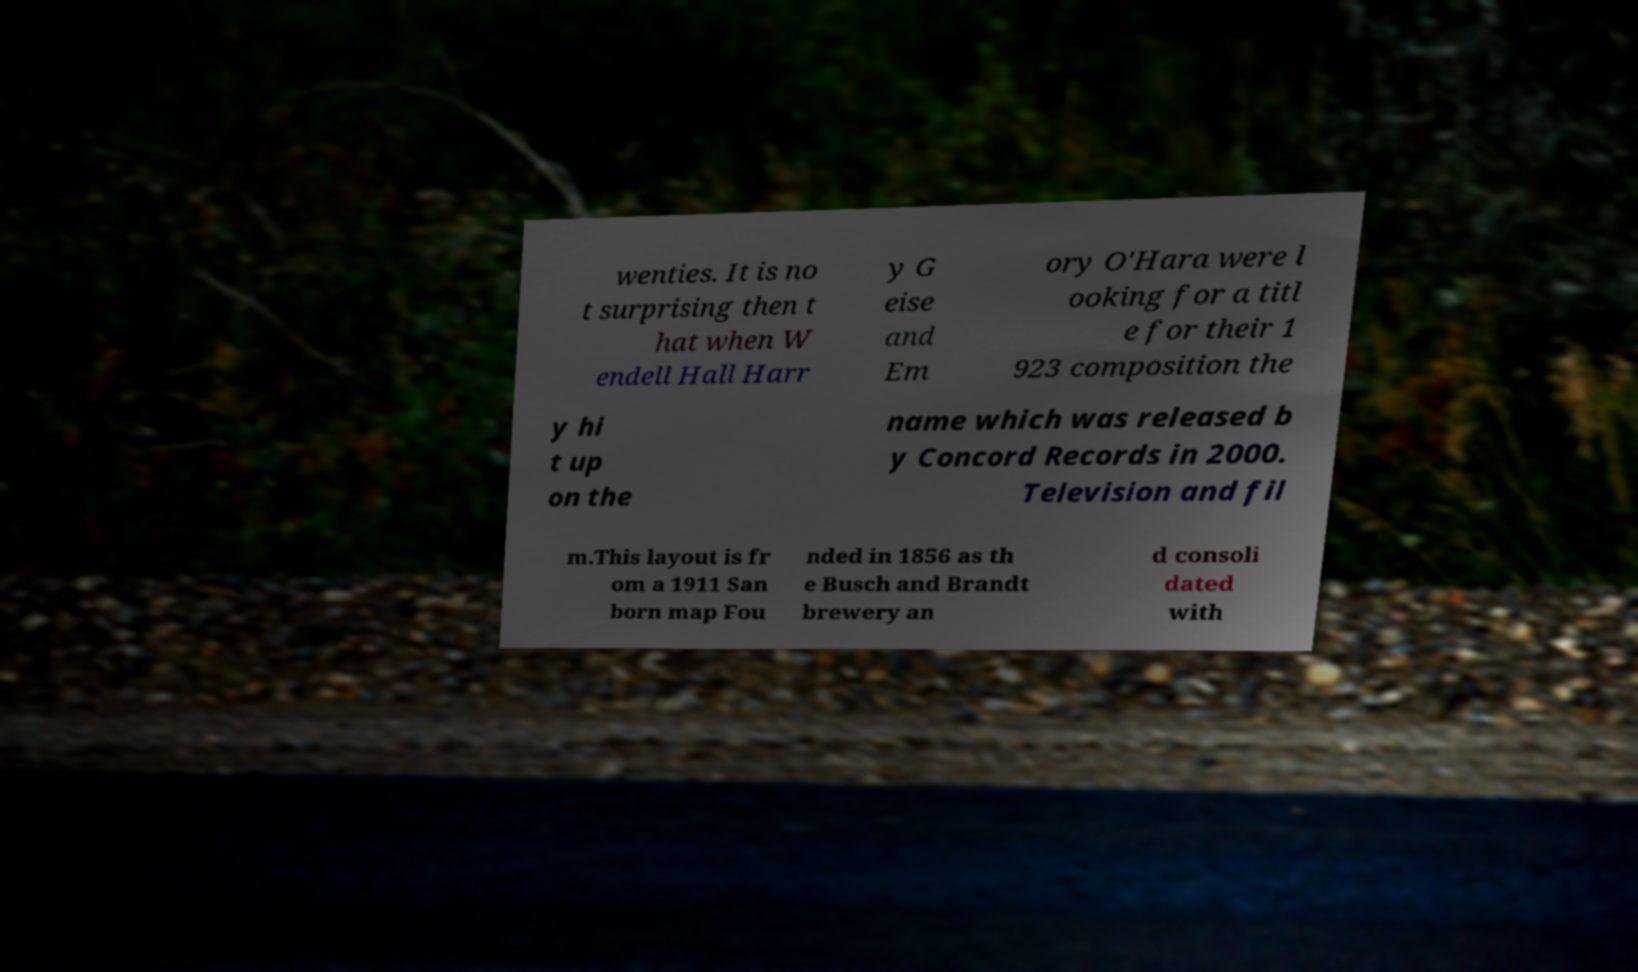Can you accurately transcribe the text from the provided image for me? wenties. It is no t surprising then t hat when W endell Hall Harr y G eise and Em ory O'Hara were l ooking for a titl e for their 1 923 composition the y hi t up on the name which was released b y Concord Records in 2000. Television and fil m.This layout is fr om a 1911 San born map Fou nded in 1856 as th e Busch and Brandt brewery an d consoli dated with 